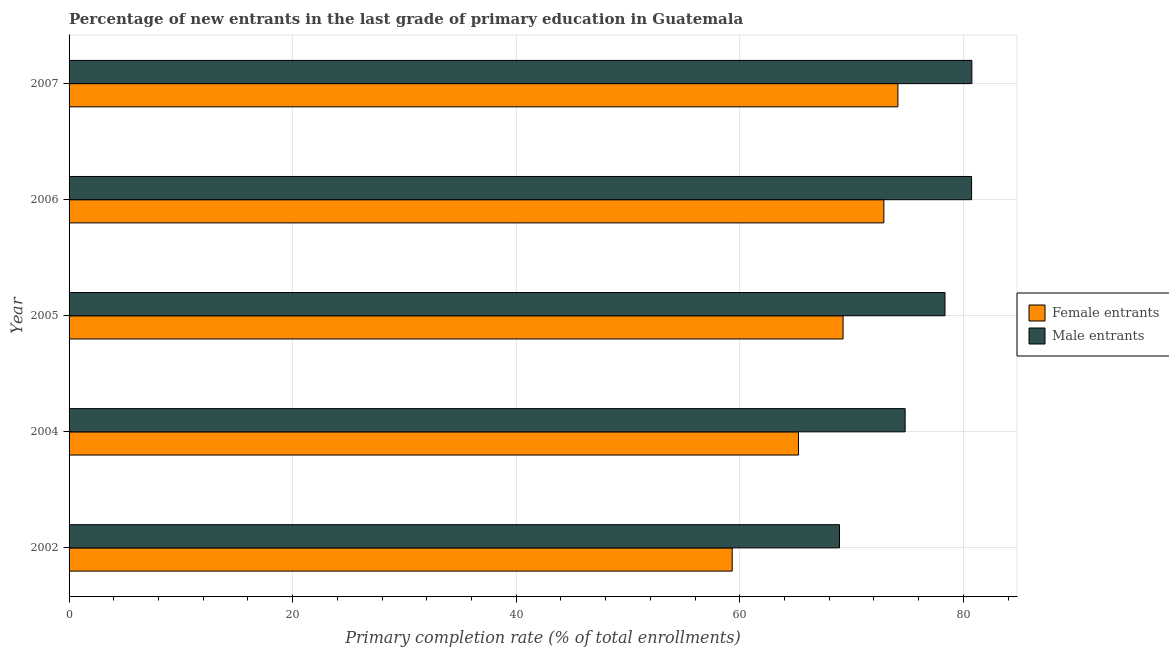How many different coloured bars are there?
Your response must be concise. 2. How many groups of bars are there?
Your answer should be compact. 5. Are the number of bars per tick equal to the number of legend labels?
Provide a short and direct response. Yes. How many bars are there on the 4th tick from the bottom?
Offer a very short reply. 2. What is the label of the 1st group of bars from the top?
Keep it short and to the point. 2007. What is the primary completion rate of female entrants in 2006?
Keep it short and to the point. 72.89. Across all years, what is the maximum primary completion rate of male entrants?
Keep it short and to the point. 80.76. Across all years, what is the minimum primary completion rate of female entrants?
Your answer should be compact. 59.32. In which year was the primary completion rate of female entrants maximum?
Keep it short and to the point. 2007. In which year was the primary completion rate of male entrants minimum?
Ensure brevity in your answer.  2002. What is the total primary completion rate of female entrants in the graph?
Your answer should be very brief. 340.85. What is the difference between the primary completion rate of female entrants in 2005 and that in 2006?
Give a very brief answer. -3.65. What is the difference between the primary completion rate of male entrants in 2004 and the primary completion rate of female entrants in 2006?
Ensure brevity in your answer.  1.9. What is the average primary completion rate of male entrants per year?
Provide a short and direct response. 76.71. In the year 2002, what is the difference between the primary completion rate of male entrants and primary completion rate of female entrants?
Your answer should be very brief. 9.6. In how many years, is the primary completion rate of male entrants greater than 72 %?
Your response must be concise. 4. What is the ratio of the primary completion rate of male entrants in 2002 to that in 2007?
Ensure brevity in your answer.  0.85. Is the primary completion rate of female entrants in 2002 less than that in 2004?
Offer a very short reply. Yes. What is the difference between the highest and the second highest primary completion rate of male entrants?
Ensure brevity in your answer.  0.03. What is the difference between the highest and the lowest primary completion rate of female entrants?
Make the answer very short. 14.83. What does the 1st bar from the top in 2006 represents?
Provide a short and direct response. Male entrants. What does the 2nd bar from the bottom in 2007 represents?
Make the answer very short. Male entrants. Are all the bars in the graph horizontal?
Keep it short and to the point. Yes. How many years are there in the graph?
Provide a succinct answer. 5. What is the difference between two consecutive major ticks on the X-axis?
Provide a short and direct response. 20. How are the legend labels stacked?
Make the answer very short. Vertical. What is the title of the graph?
Your answer should be very brief. Percentage of new entrants in the last grade of primary education in Guatemala. Does "Formally registered" appear as one of the legend labels in the graph?
Keep it short and to the point. No. What is the label or title of the X-axis?
Your response must be concise. Primary completion rate (% of total enrollments). What is the Primary completion rate (% of total enrollments) of Female entrants in 2002?
Give a very brief answer. 59.32. What is the Primary completion rate (% of total enrollments) of Male entrants in 2002?
Your answer should be very brief. 68.92. What is the Primary completion rate (% of total enrollments) in Female entrants in 2004?
Offer a terse response. 65.25. What is the Primary completion rate (% of total enrollments) in Male entrants in 2004?
Your answer should be compact. 74.79. What is the Primary completion rate (% of total enrollments) in Female entrants in 2005?
Provide a short and direct response. 69.24. What is the Primary completion rate (% of total enrollments) of Male entrants in 2005?
Your answer should be very brief. 78.36. What is the Primary completion rate (% of total enrollments) in Female entrants in 2006?
Your answer should be very brief. 72.89. What is the Primary completion rate (% of total enrollments) in Male entrants in 2006?
Offer a very short reply. 80.74. What is the Primary completion rate (% of total enrollments) in Female entrants in 2007?
Offer a terse response. 74.15. What is the Primary completion rate (% of total enrollments) in Male entrants in 2007?
Offer a very short reply. 80.76. Across all years, what is the maximum Primary completion rate (% of total enrollments) of Female entrants?
Make the answer very short. 74.15. Across all years, what is the maximum Primary completion rate (% of total enrollments) of Male entrants?
Your answer should be compact. 80.76. Across all years, what is the minimum Primary completion rate (% of total enrollments) of Female entrants?
Offer a terse response. 59.32. Across all years, what is the minimum Primary completion rate (% of total enrollments) in Male entrants?
Ensure brevity in your answer.  68.92. What is the total Primary completion rate (% of total enrollments) in Female entrants in the graph?
Give a very brief answer. 340.85. What is the total Primary completion rate (% of total enrollments) in Male entrants in the graph?
Your response must be concise. 383.57. What is the difference between the Primary completion rate (% of total enrollments) of Female entrants in 2002 and that in 2004?
Provide a succinct answer. -5.93. What is the difference between the Primary completion rate (% of total enrollments) in Male entrants in 2002 and that in 2004?
Give a very brief answer. -5.87. What is the difference between the Primary completion rate (% of total enrollments) in Female entrants in 2002 and that in 2005?
Provide a succinct answer. -9.92. What is the difference between the Primary completion rate (% of total enrollments) in Male entrants in 2002 and that in 2005?
Make the answer very short. -9.44. What is the difference between the Primary completion rate (% of total enrollments) of Female entrants in 2002 and that in 2006?
Give a very brief answer. -13.57. What is the difference between the Primary completion rate (% of total enrollments) in Male entrants in 2002 and that in 2006?
Provide a short and direct response. -11.82. What is the difference between the Primary completion rate (% of total enrollments) in Female entrants in 2002 and that in 2007?
Your response must be concise. -14.83. What is the difference between the Primary completion rate (% of total enrollments) of Male entrants in 2002 and that in 2007?
Ensure brevity in your answer.  -11.84. What is the difference between the Primary completion rate (% of total enrollments) of Female entrants in 2004 and that in 2005?
Give a very brief answer. -3.99. What is the difference between the Primary completion rate (% of total enrollments) in Male entrants in 2004 and that in 2005?
Offer a terse response. -3.57. What is the difference between the Primary completion rate (% of total enrollments) in Female entrants in 2004 and that in 2006?
Offer a very short reply. -7.64. What is the difference between the Primary completion rate (% of total enrollments) of Male entrants in 2004 and that in 2006?
Make the answer very short. -5.94. What is the difference between the Primary completion rate (% of total enrollments) in Female entrants in 2004 and that in 2007?
Your response must be concise. -8.9. What is the difference between the Primary completion rate (% of total enrollments) in Male entrants in 2004 and that in 2007?
Give a very brief answer. -5.97. What is the difference between the Primary completion rate (% of total enrollments) of Female entrants in 2005 and that in 2006?
Your response must be concise. -3.65. What is the difference between the Primary completion rate (% of total enrollments) of Male entrants in 2005 and that in 2006?
Your response must be concise. -2.38. What is the difference between the Primary completion rate (% of total enrollments) of Female entrants in 2005 and that in 2007?
Ensure brevity in your answer.  -4.91. What is the difference between the Primary completion rate (% of total enrollments) of Male entrants in 2005 and that in 2007?
Provide a succinct answer. -2.4. What is the difference between the Primary completion rate (% of total enrollments) in Female entrants in 2006 and that in 2007?
Offer a terse response. -1.26. What is the difference between the Primary completion rate (% of total enrollments) in Male entrants in 2006 and that in 2007?
Your answer should be very brief. -0.03. What is the difference between the Primary completion rate (% of total enrollments) of Female entrants in 2002 and the Primary completion rate (% of total enrollments) of Male entrants in 2004?
Provide a short and direct response. -15.47. What is the difference between the Primary completion rate (% of total enrollments) of Female entrants in 2002 and the Primary completion rate (% of total enrollments) of Male entrants in 2005?
Your answer should be compact. -19.04. What is the difference between the Primary completion rate (% of total enrollments) in Female entrants in 2002 and the Primary completion rate (% of total enrollments) in Male entrants in 2006?
Provide a succinct answer. -21.41. What is the difference between the Primary completion rate (% of total enrollments) in Female entrants in 2002 and the Primary completion rate (% of total enrollments) in Male entrants in 2007?
Ensure brevity in your answer.  -21.44. What is the difference between the Primary completion rate (% of total enrollments) of Female entrants in 2004 and the Primary completion rate (% of total enrollments) of Male entrants in 2005?
Your response must be concise. -13.11. What is the difference between the Primary completion rate (% of total enrollments) in Female entrants in 2004 and the Primary completion rate (% of total enrollments) in Male entrants in 2006?
Your answer should be very brief. -15.49. What is the difference between the Primary completion rate (% of total enrollments) of Female entrants in 2004 and the Primary completion rate (% of total enrollments) of Male entrants in 2007?
Provide a succinct answer. -15.51. What is the difference between the Primary completion rate (% of total enrollments) of Female entrants in 2005 and the Primary completion rate (% of total enrollments) of Male entrants in 2006?
Give a very brief answer. -11.49. What is the difference between the Primary completion rate (% of total enrollments) of Female entrants in 2005 and the Primary completion rate (% of total enrollments) of Male entrants in 2007?
Your response must be concise. -11.52. What is the difference between the Primary completion rate (% of total enrollments) of Female entrants in 2006 and the Primary completion rate (% of total enrollments) of Male entrants in 2007?
Provide a short and direct response. -7.87. What is the average Primary completion rate (% of total enrollments) in Female entrants per year?
Offer a very short reply. 68.17. What is the average Primary completion rate (% of total enrollments) in Male entrants per year?
Offer a very short reply. 76.71. In the year 2002, what is the difference between the Primary completion rate (% of total enrollments) of Female entrants and Primary completion rate (% of total enrollments) of Male entrants?
Provide a short and direct response. -9.6. In the year 2004, what is the difference between the Primary completion rate (% of total enrollments) of Female entrants and Primary completion rate (% of total enrollments) of Male entrants?
Give a very brief answer. -9.54. In the year 2005, what is the difference between the Primary completion rate (% of total enrollments) in Female entrants and Primary completion rate (% of total enrollments) in Male entrants?
Provide a short and direct response. -9.12. In the year 2006, what is the difference between the Primary completion rate (% of total enrollments) in Female entrants and Primary completion rate (% of total enrollments) in Male entrants?
Your answer should be compact. -7.85. In the year 2007, what is the difference between the Primary completion rate (% of total enrollments) of Female entrants and Primary completion rate (% of total enrollments) of Male entrants?
Provide a succinct answer. -6.62. What is the ratio of the Primary completion rate (% of total enrollments) of Male entrants in 2002 to that in 2004?
Provide a succinct answer. 0.92. What is the ratio of the Primary completion rate (% of total enrollments) in Female entrants in 2002 to that in 2005?
Your answer should be compact. 0.86. What is the ratio of the Primary completion rate (% of total enrollments) of Male entrants in 2002 to that in 2005?
Provide a short and direct response. 0.88. What is the ratio of the Primary completion rate (% of total enrollments) in Female entrants in 2002 to that in 2006?
Offer a very short reply. 0.81. What is the ratio of the Primary completion rate (% of total enrollments) of Male entrants in 2002 to that in 2006?
Your answer should be compact. 0.85. What is the ratio of the Primary completion rate (% of total enrollments) in Male entrants in 2002 to that in 2007?
Offer a terse response. 0.85. What is the ratio of the Primary completion rate (% of total enrollments) in Female entrants in 2004 to that in 2005?
Make the answer very short. 0.94. What is the ratio of the Primary completion rate (% of total enrollments) in Male entrants in 2004 to that in 2005?
Provide a succinct answer. 0.95. What is the ratio of the Primary completion rate (% of total enrollments) of Female entrants in 2004 to that in 2006?
Provide a succinct answer. 0.9. What is the ratio of the Primary completion rate (% of total enrollments) of Male entrants in 2004 to that in 2006?
Make the answer very short. 0.93. What is the ratio of the Primary completion rate (% of total enrollments) of Male entrants in 2004 to that in 2007?
Ensure brevity in your answer.  0.93. What is the ratio of the Primary completion rate (% of total enrollments) in Male entrants in 2005 to that in 2006?
Offer a very short reply. 0.97. What is the ratio of the Primary completion rate (% of total enrollments) of Female entrants in 2005 to that in 2007?
Provide a succinct answer. 0.93. What is the ratio of the Primary completion rate (% of total enrollments) of Male entrants in 2005 to that in 2007?
Keep it short and to the point. 0.97. What is the ratio of the Primary completion rate (% of total enrollments) of Female entrants in 2006 to that in 2007?
Offer a very short reply. 0.98. What is the difference between the highest and the second highest Primary completion rate (% of total enrollments) in Female entrants?
Your answer should be compact. 1.26. What is the difference between the highest and the second highest Primary completion rate (% of total enrollments) of Male entrants?
Ensure brevity in your answer.  0.03. What is the difference between the highest and the lowest Primary completion rate (% of total enrollments) in Female entrants?
Give a very brief answer. 14.83. What is the difference between the highest and the lowest Primary completion rate (% of total enrollments) in Male entrants?
Give a very brief answer. 11.84. 